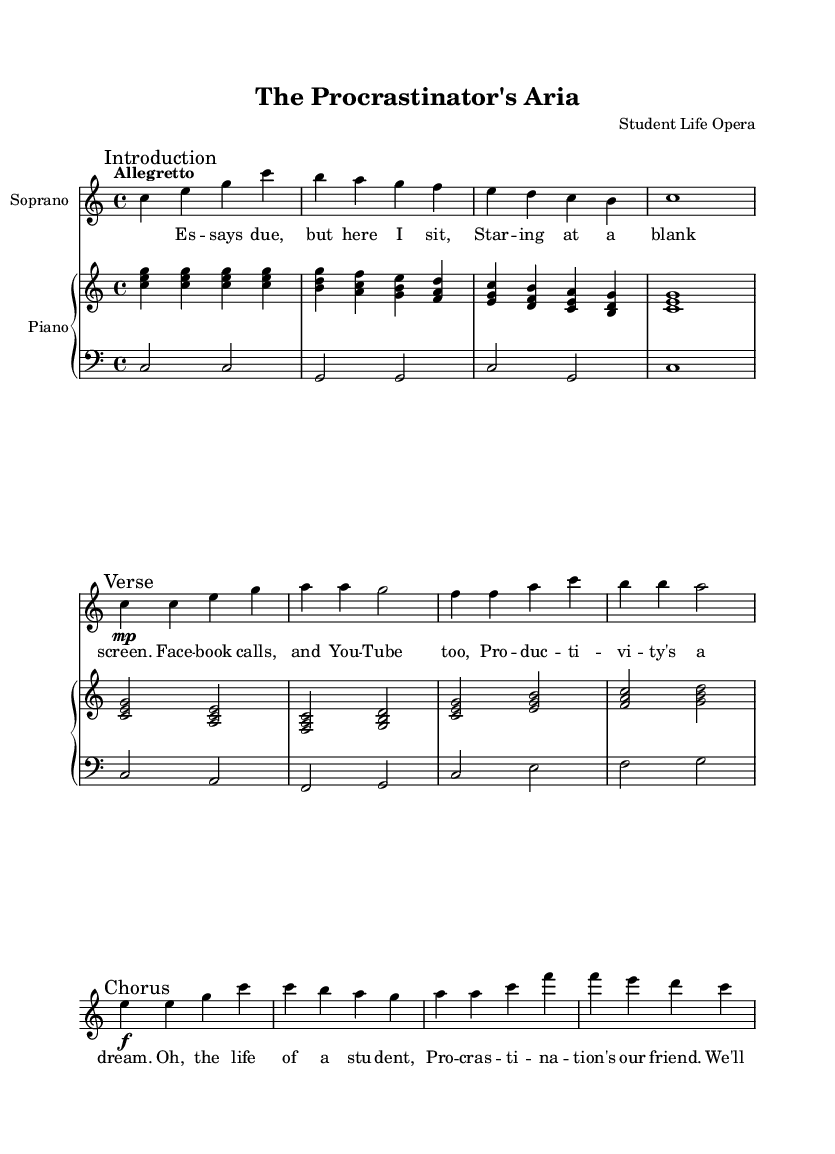What is the key signature of this music? The key signature is C major, which has no sharps or flats.
Answer: C major What is the time signature of the piece? The time signature indicated at the beginning of the sheet music is 4/4, meaning there are four beats in each measure.
Answer: 4/4 What is the tempo marking for this aria? The tempo marking given in the score is "Allegretto," indicating a moderately fast tempo.
Answer: Allegretto How many measures are in the introductory section? The introductory section consists of 4 measures, as indicated by the number of bar lines before the verse starts.
Answer: 4 measures What dynamics are specified at the beginning of the verse? The dynamics specified for the verse indicate a change to "mp," which stands for mezzo-piano, a moderately soft volume.
Answer: mp What kind of musical form is used in the piece? The piece follows a typical structure for arias, consisting of an introduction, followed by verses and a chorus, supporting its opera nature.
Answer: Aria What humorous theme is presented in the lyrics of the aria? The lyrics humorously express the struggles and procrastination commonly experienced by students, highlighting their challenges in maintaining productivity.
Answer: Procrastination 